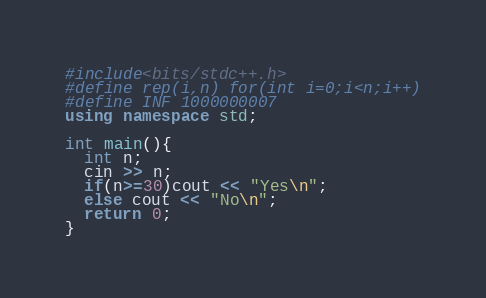<code> <loc_0><loc_0><loc_500><loc_500><_C++_>#include<bits/stdc++.h>
#define rep(i,n) for(int i=0;i<n;i++)
#define INF 1000000007
using namespace std;

int main(){
  int n;
  cin >> n;
  if(n>=30)cout << "Yes\n";
  else cout << "No\n";
  return 0;
}</code> 